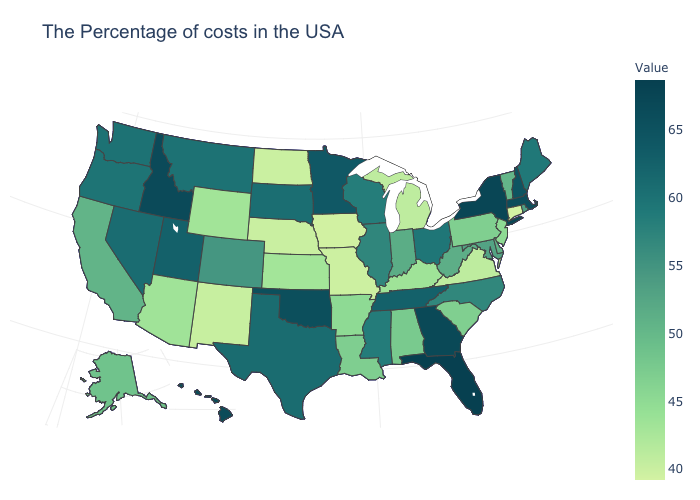Does Wisconsin have the lowest value in the USA?
Give a very brief answer. No. Is the legend a continuous bar?
Keep it brief. Yes. Does Alabama have a higher value than Oklahoma?
Be succinct. No. Among the states that border Nebraska , does Iowa have the lowest value?
Concise answer only. Yes. Among the states that border Missouri , which have the lowest value?
Keep it brief. Iowa. 